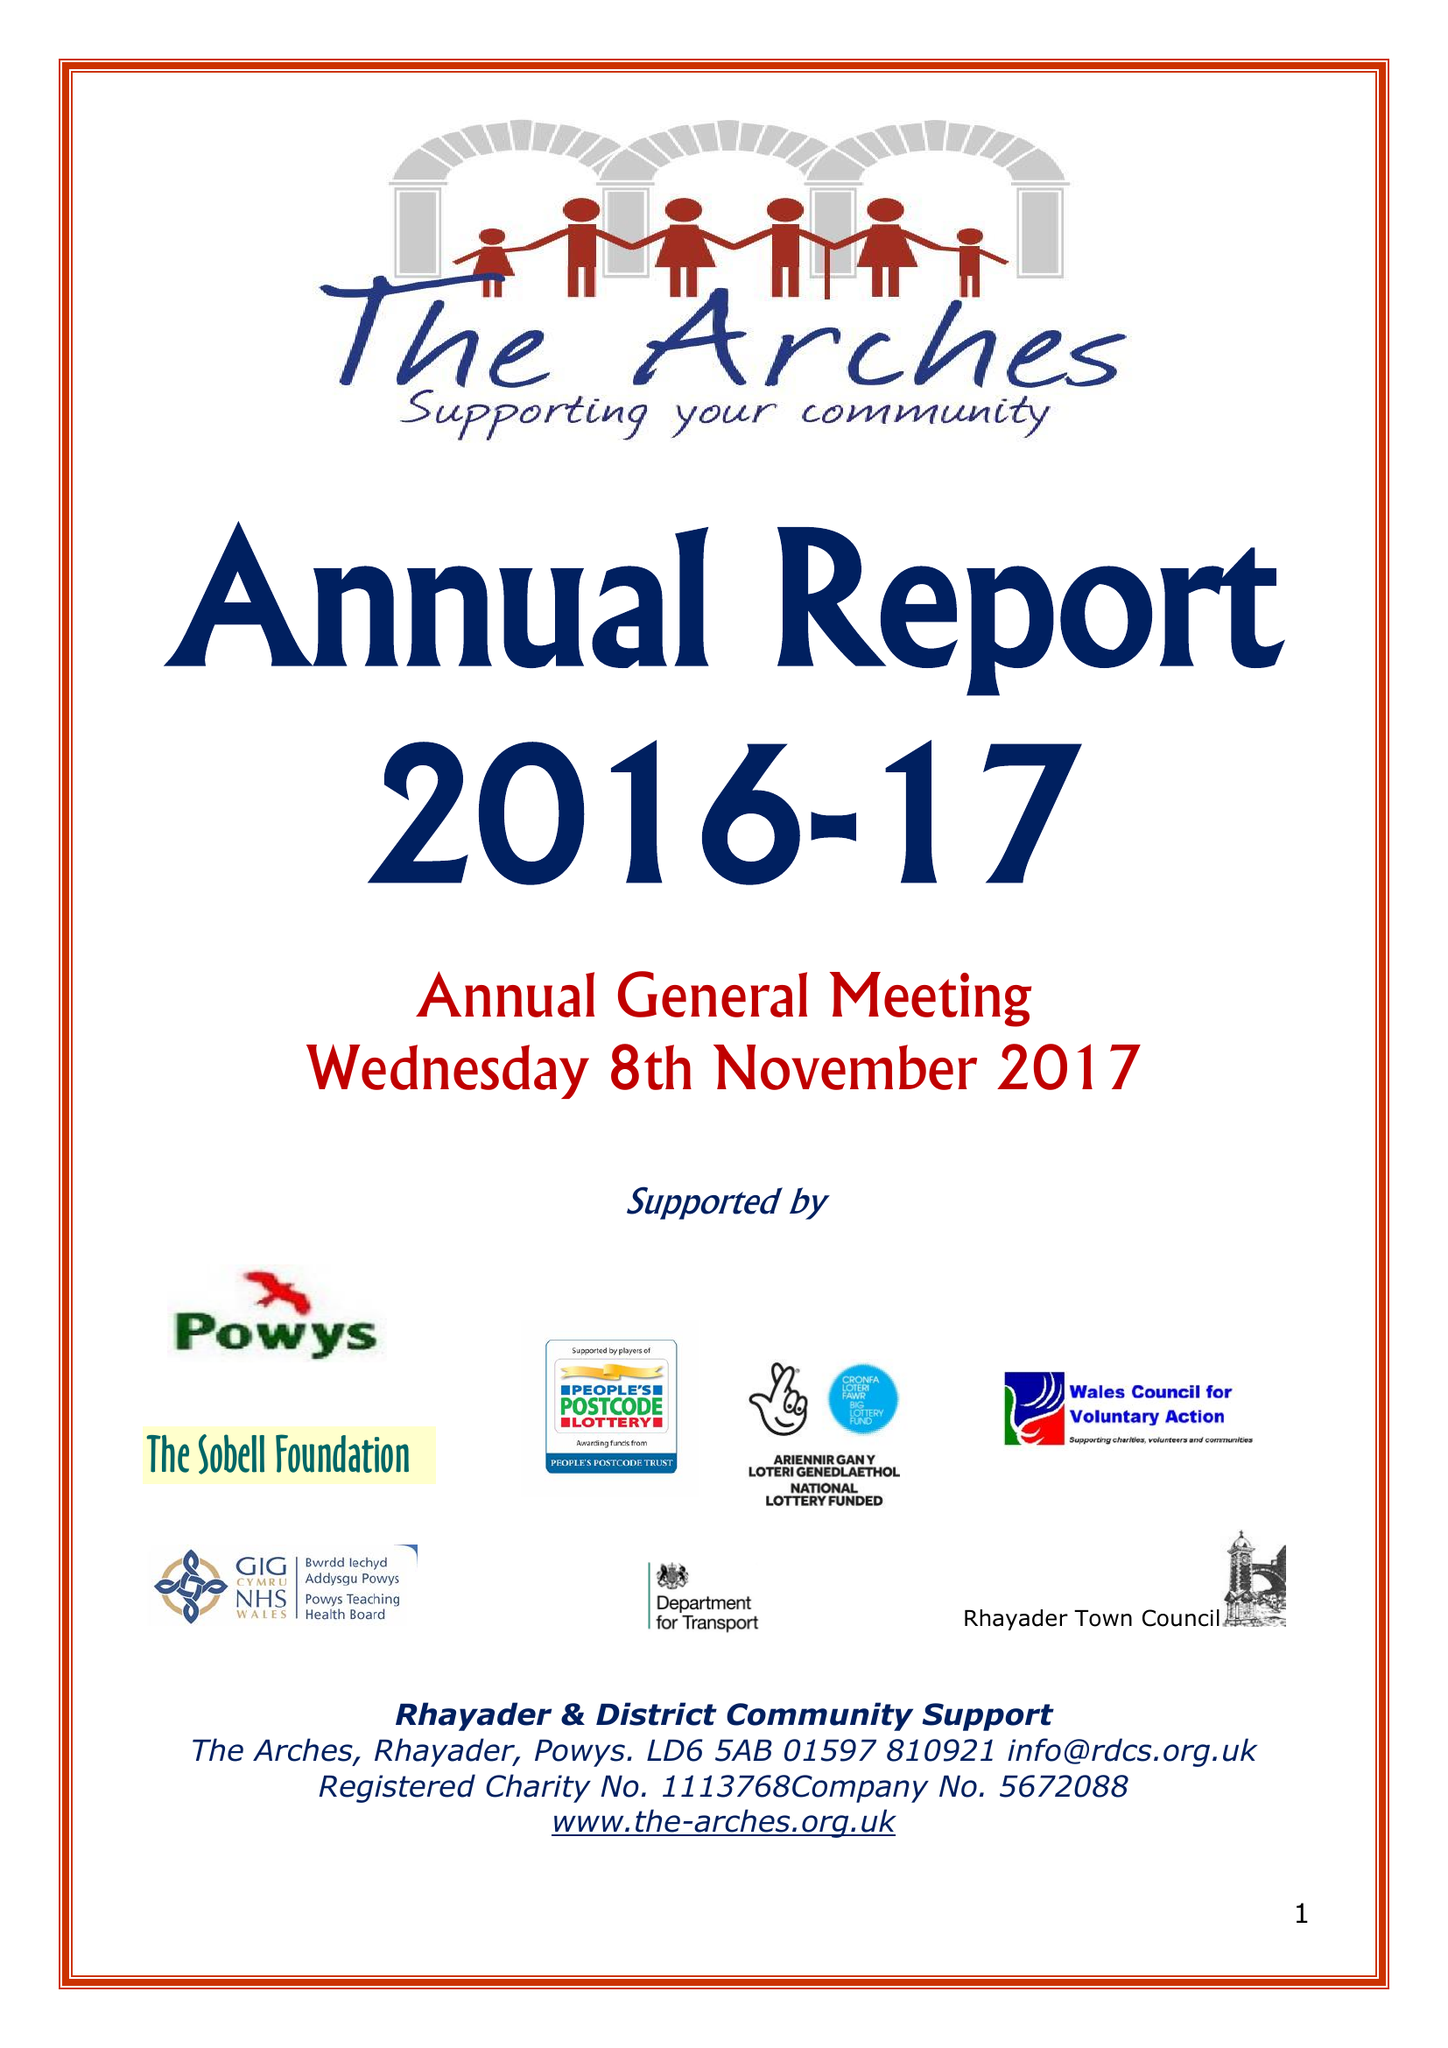What is the value for the charity_number?
Answer the question using a single word or phrase. 1113768 